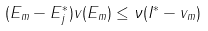Convert formula to latex. <formula><loc_0><loc_0><loc_500><loc_500>( E _ { m } - E _ { j } ^ { * } ) v ( E _ { m } ) \leq \nu ( I ^ { * } - v _ { m } )</formula> 